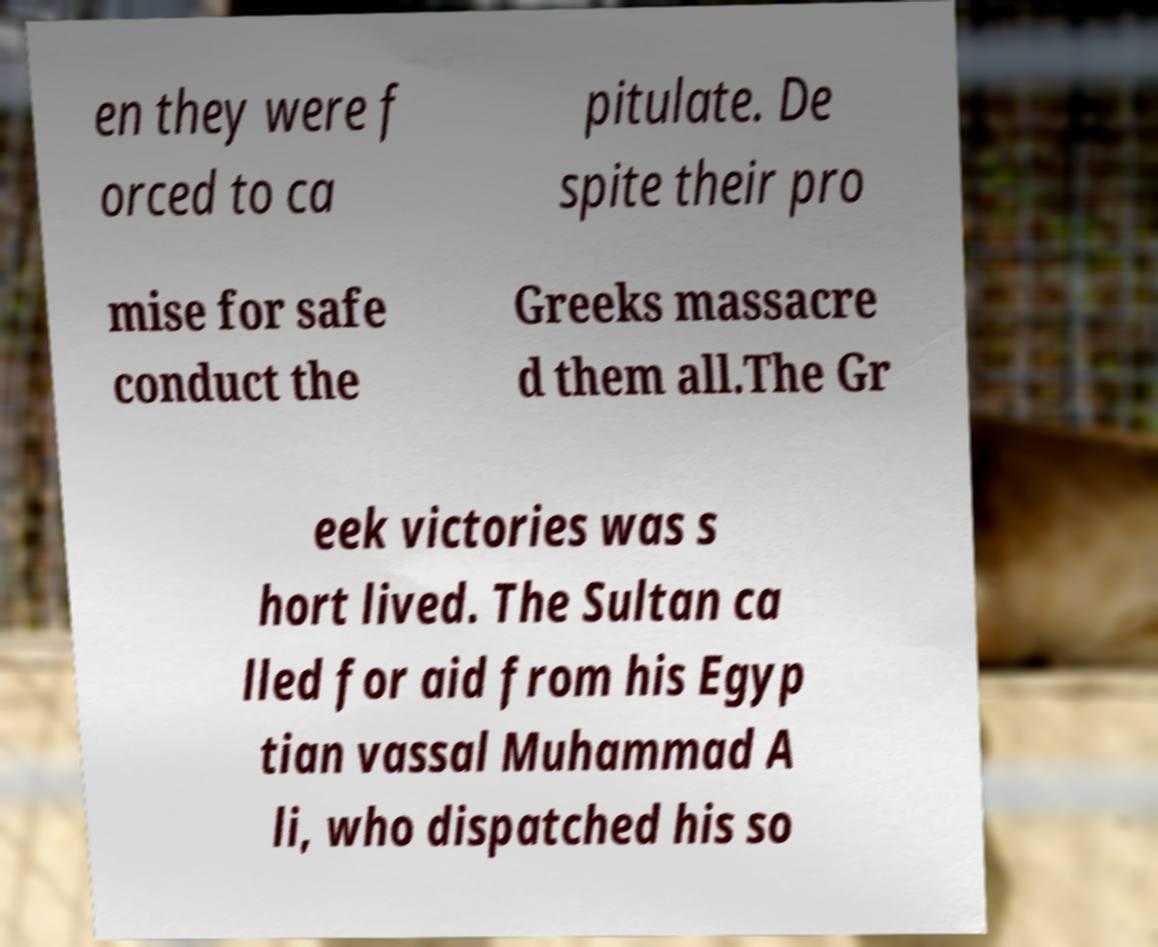Can you read and provide the text displayed in the image?This photo seems to have some interesting text. Can you extract and type it out for me? en they were f orced to ca pitulate. De spite their pro mise for safe conduct the Greeks massacre d them all.The Gr eek victories was s hort lived. The Sultan ca lled for aid from his Egyp tian vassal Muhammad A li, who dispatched his so 